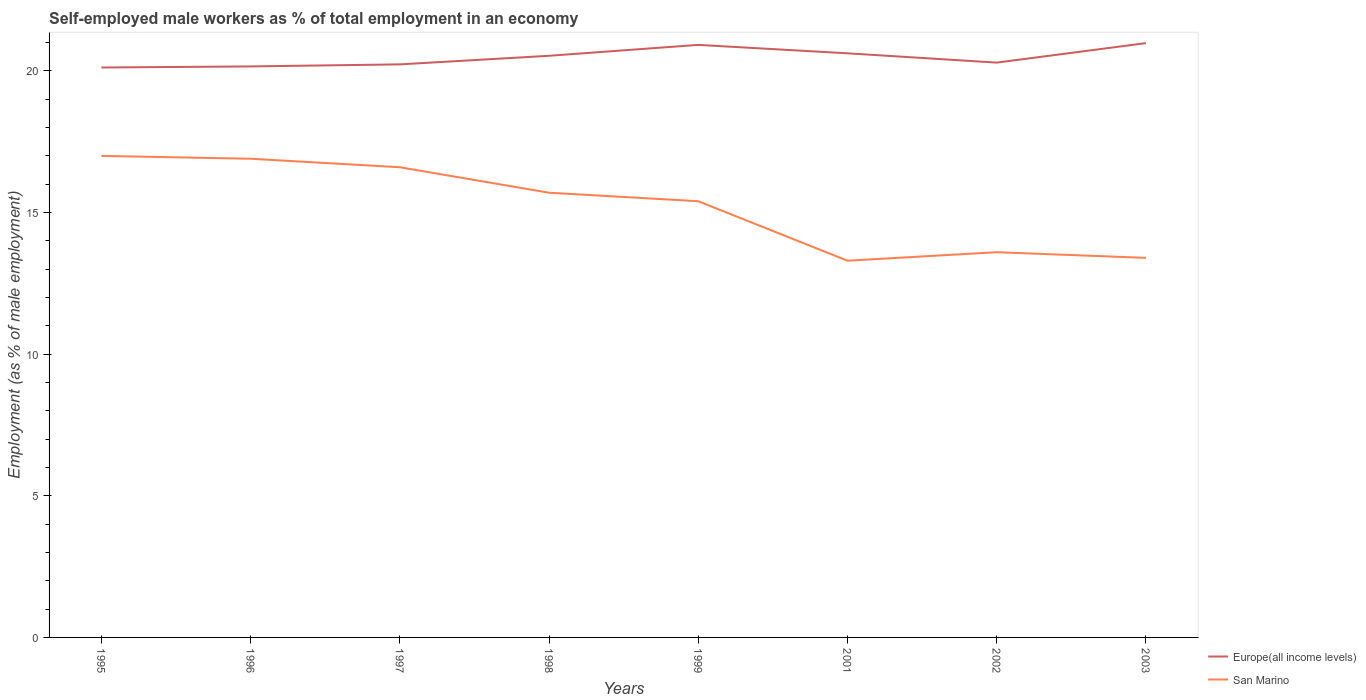Is the number of lines equal to the number of legend labels?
Your answer should be compact. Yes. Across all years, what is the maximum percentage of self-employed male workers in Europe(all income levels)?
Make the answer very short. 20.12. In which year was the percentage of self-employed male workers in Europe(all income levels) maximum?
Your response must be concise. 1995. What is the total percentage of self-employed male workers in Europe(all income levels) in the graph?
Give a very brief answer. -0.86. What is the difference between the highest and the second highest percentage of self-employed male workers in San Marino?
Offer a very short reply. 3.7. What is the difference between the highest and the lowest percentage of self-employed male workers in San Marino?
Keep it short and to the point. 5. Is the percentage of self-employed male workers in Europe(all income levels) strictly greater than the percentage of self-employed male workers in San Marino over the years?
Keep it short and to the point. No. How many lines are there?
Offer a very short reply. 2. How many years are there in the graph?
Your answer should be very brief. 8. What is the difference between two consecutive major ticks on the Y-axis?
Your answer should be compact. 5. Are the values on the major ticks of Y-axis written in scientific E-notation?
Make the answer very short. No. Does the graph contain any zero values?
Your answer should be very brief. No. How are the legend labels stacked?
Offer a very short reply. Vertical. What is the title of the graph?
Provide a succinct answer. Self-employed male workers as % of total employment in an economy. Does "Sri Lanka" appear as one of the legend labels in the graph?
Offer a very short reply. No. What is the label or title of the X-axis?
Give a very brief answer. Years. What is the label or title of the Y-axis?
Provide a succinct answer. Employment (as % of male employment). What is the Employment (as % of male employment) of Europe(all income levels) in 1995?
Your answer should be compact. 20.12. What is the Employment (as % of male employment) in Europe(all income levels) in 1996?
Offer a very short reply. 20.16. What is the Employment (as % of male employment) of San Marino in 1996?
Offer a terse response. 16.9. What is the Employment (as % of male employment) in Europe(all income levels) in 1997?
Ensure brevity in your answer.  20.23. What is the Employment (as % of male employment) of San Marino in 1997?
Keep it short and to the point. 16.6. What is the Employment (as % of male employment) of Europe(all income levels) in 1998?
Your response must be concise. 20.53. What is the Employment (as % of male employment) of San Marino in 1998?
Your response must be concise. 15.7. What is the Employment (as % of male employment) of Europe(all income levels) in 1999?
Offer a very short reply. 20.92. What is the Employment (as % of male employment) in San Marino in 1999?
Your answer should be compact. 15.4. What is the Employment (as % of male employment) in Europe(all income levels) in 2001?
Your answer should be compact. 20.62. What is the Employment (as % of male employment) in San Marino in 2001?
Ensure brevity in your answer.  13.3. What is the Employment (as % of male employment) in Europe(all income levels) in 2002?
Offer a terse response. 20.29. What is the Employment (as % of male employment) of San Marino in 2002?
Offer a terse response. 13.6. What is the Employment (as % of male employment) in Europe(all income levels) in 2003?
Provide a succinct answer. 20.98. What is the Employment (as % of male employment) in San Marino in 2003?
Provide a succinct answer. 13.4. Across all years, what is the maximum Employment (as % of male employment) in Europe(all income levels)?
Keep it short and to the point. 20.98. Across all years, what is the maximum Employment (as % of male employment) of San Marino?
Provide a short and direct response. 17. Across all years, what is the minimum Employment (as % of male employment) in Europe(all income levels)?
Provide a short and direct response. 20.12. Across all years, what is the minimum Employment (as % of male employment) in San Marino?
Ensure brevity in your answer.  13.3. What is the total Employment (as % of male employment) in Europe(all income levels) in the graph?
Provide a succinct answer. 163.86. What is the total Employment (as % of male employment) in San Marino in the graph?
Your answer should be very brief. 121.9. What is the difference between the Employment (as % of male employment) in Europe(all income levels) in 1995 and that in 1996?
Make the answer very short. -0.04. What is the difference between the Employment (as % of male employment) of Europe(all income levels) in 1995 and that in 1997?
Your answer should be very brief. -0.11. What is the difference between the Employment (as % of male employment) in Europe(all income levels) in 1995 and that in 1998?
Your answer should be compact. -0.41. What is the difference between the Employment (as % of male employment) in San Marino in 1995 and that in 1998?
Your answer should be very brief. 1.3. What is the difference between the Employment (as % of male employment) of Europe(all income levels) in 1995 and that in 1999?
Your answer should be very brief. -0.8. What is the difference between the Employment (as % of male employment) of San Marino in 1995 and that in 1999?
Provide a succinct answer. 1.6. What is the difference between the Employment (as % of male employment) in Europe(all income levels) in 1995 and that in 2001?
Give a very brief answer. -0.5. What is the difference between the Employment (as % of male employment) of San Marino in 1995 and that in 2001?
Provide a succinct answer. 3.7. What is the difference between the Employment (as % of male employment) of Europe(all income levels) in 1995 and that in 2002?
Keep it short and to the point. -0.17. What is the difference between the Employment (as % of male employment) in San Marino in 1995 and that in 2002?
Ensure brevity in your answer.  3.4. What is the difference between the Employment (as % of male employment) in Europe(all income levels) in 1995 and that in 2003?
Your response must be concise. -0.86. What is the difference between the Employment (as % of male employment) in Europe(all income levels) in 1996 and that in 1997?
Ensure brevity in your answer.  -0.07. What is the difference between the Employment (as % of male employment) of Europe(all income levels) in 1996 and that in 1998?
Your answer should be compact. -0.38. What is the difference between the Employment (as % of male employment) of Europe(all income levels) in 1996 and that in 1999?
Your response must be concise. -0.76. What is the difference between the Employment (as % of male employment) of Europe(all income levels) in 1996 and that in 2001?
Ensure brevity in your answer.  -0.46. What is the difference between the Employment (as % of male employment) in San Marino in 1996 and that in 2001?
Keep it short and to the point. 3.6. What is the difference between the Employment (as % of male employment) in Europe(all income levels) in 1996 and that in 2002?
Your answer should be very brief. -0.13. What is the difference between the Employment (as % of male employment) in San Marino in 1996 and that in 2002?
Ensure brevity in your answer.  3.3. What is the difference between the Employment (as % of male employment) of Europe(all income levels) in 1996 and that in 2003?
Your answer should be compact. -0.82. What is the difference between the Employment (as % of male employment) of Europe(all income levels) in 1997 and that in 1998?
Provide a succinct answer. -0.3. What is the difference between the Employment (as % of male employment) in Europe(all income levels) in 1997 and that in 1999?
Your answer should be very brief. -0.69. What is the difference between the Employment (as % of male employment) in San Marino in 1997 and that in 1999?
Keep it short and to the point. 1.2. What is the difference between the Employment (as % of male employment) of Europe(all income levels) in 1997 and that in 2001?
Keep it short and to the point. -0.39. What is the difference between the Employment (as % of male employment) in Europe(all income levels) in 1997 and that in 2002?
Ensure brevity in your answer.  -0.06. What is the difference between the Employment (as % of male employment) of Europe(all income levels) in 1997 and that in 2003?
Keep it short and to the point. -0.75. What is the difference between the Employment (as % of male employment) in Europe(all income levels) in 1998 and that in 1999?
Provide a succinct answer. -0.39. What is the difference between the Employment (as % of male employment) of San Marino in 1998 and that in 1999?
Keep it short and to the point. 0.3. What is the difference between the Employment (as % of male employment) in Europe(all income levels) in 1998 and that in 2001?
Offer a very short reply. -0.09. What is the difference between the Employment (as % of male employment) of San Marino in 1998 and that in 2001?
Ensure brevity in your answer.  2.4. What is the difference between the Employment (as % of male employment) in Europe(all income levels) in 1998 and that in 2002?
Your answer should be very brief. 0.24. What is the difference between the Employment (as % of male employment) in San Marino in 1998 and that in 2002?
Keep it short and to the point. 2.1. What is the difference between the Employment (as % of male employment) of Europe(all income levels) in 1998 and that in 2003?
Provide a succinct answer. -0.45. What is the difference between the Employment (as % of male employment) in San Marino in 1998 and that in 2003?
Provide a succinct answer. 2.3. What is the difference between the Employment (as % of male employment) in Europe(all income levels) in 1999 and that in 2001?
Your answer should be compact. 0.3. What is the difference between the Employment (as % of male employment) of Europe(all income levels) in 1999 and that in 2002?
Offer a terse response. 0.63. What is the difference between the Employment (as % of male employment) in Europe(all income levels) in 1999 and that in 2003?
Offer a terse response. -0.06. What is the difference between the Employment (as % of male employment) in San Marino in 1999 and that in 2003?
Your response must be concise. 2. What is the difference between the Employment (as % of male employment) of Europe(all income levels) in 2001 and that in 2002?
Keep it short and to the point. 0.33. What is the difference between the Employment (as % of male employment) of Europe(all income levels) in 2001 and that in 2003?
Provide a succinct answer. -0.36. What is the difference between the Employment (as % of male employment) in Europe(all income levels) in 2002 and that in 2003?
Your response must be concise. -0.69. What is the difference between the Employment (as % of male employment) of Europe(all income levels) in 1995 and the Employment (as % of male employment) of San Marino in 1996?
Keep it short and to the point. 3.22. What is the difference between the Employment (as % of male employment) of Europe(all income levels) in 1995 and the Employment (as % of male employment) of San Marino in 1997?
Offer a terse response. 3.52. What is the difference between the Employment (as % of male employment) of Europe(all income levels) in 1995 and the Employment (as % of male employment) of San Marino in 1998?
Offer a very short reply. 4.42. What is the difference between the Employment (as % of male employment) of Europe(all income levels) in 1995 and the Employment (as % of male employment) of San Marino in 1999?
Your answer should be compact. 4.72. What is the difference between the Employment (as % of male employment) in Europe(all income levels) in 1995 and the Employment (as % of male employment) in San Marino in 2001?
Keep it short and to the point. 6.82. What is the difference between the Employment (as % of male employment) of Europe(all income levels) in 1995 and the Employment (as % of male employment) of San Marino in 2002?
Your answer should be very brief. 6.52. What is the difference between the Employment (as % of male employment) of Europe(all income levels) in 1995 and the Employment (as % of male employment) of San Marino in 2003?
Keep it short and to the point. 6.72. What is the difference between the Employment (as % of male employment) of Europe(all income levels) in 1996 and the Employment (as % of male employment) of San Marino in 1997?
Ensure brevity in your answer.  3.56. What is the difference between the Employment (as % of male employment) in Europe(all income levels) in 1996 and the Employment (as % of male employment) in San Marino in 1998?
Give a very brief answer. 4.46. What is the difference between the Employment (as % of male employment) of Europe(all income levels) in 1996 and the Employment (as % of male employment) of San Marino in 1999?
Make the answer very short. 4.76. What is the difference between the Employment (as % of male employment) in Europe(all income levels) in 1996 and the Employment (as % of male employment) in San Marino in 2001?
Give a very brief answer. 6.86. What is the difference between the Employment (as % of male employment) of Europe(all income levels) in 1996 and the Employment (as % of male employment) of San Marino in 2002?
Ensure brevity in your answer.  6.56. What is the difference between the Employment (as % of male employment) in Europe(all income levels) in 1996 and the Employment (as % of male employment) in San Marino in 2003?
Offer a terse response. 6.76. What is the difference between the Employment (as % of male employment) in Europe(all income levels) in 1997 and the Employment (as % of male employment) in San Marino in 1998?
Offer a terse response. 4.53. What is the difference between the Employment (as % of male employment) of Europe(all income levels) in 1997 and the Employment (as % of male employment) of San Marino in 1999?
Your answer should be very brief. 4.83. What is the difference between the Employment (as % of male employment) of Europe(all income levels) in 1997 and the Employment (as % of male employment) of San Marino in 2001?
Give a very brief answer. 6.93. What is the difference between the Employment (as % of male employment) of Europe(all income levels) in 1997 and the Employment (as % of male employment) of San Marino in 2002?
Offer a very short reply. 6.63. What is the difference between the Employment (as % of male employment) in Europe(all income levels) in 1997 and the Employment (as % of male employment) in San Marino in 2003?
Your answer should be very brief. 6.83. What is the difference between the Employment (as % of male employment) in Europe(all income levels) in 1998 and the Employment (as % of male employment) in San Marino in 1999?
Offer a terse response. 5.13. What is the difference between the Employment (as % of male employment) of Europe(all income levels) in 1998 and the Employment (as % of male employment) of San Marino in 2001?
Give a very brief answer. 7.23. What is the difference between the Employment (as % of male employment) of Europe(all income levels) in 1998 and the Employment (as % of male employment) of San Marino in 2002?
Make the answer very short. 6.93. What is the difference between the Employment (as % of male employment) in Europe(all income levels) in 1998 and the Employment (as % of male employment) in San Marino in 2003?
Give a very brief answer. 7.13. What is the difference between the Employment (as % of male employment) of Europe(all income levels) in 1999 and the Employment (as % of male employment) of San Marino in 2001?
Provide a short and direct response. 7.62. What is the difference between the Employment (as % of male employment) of Europe(all income levels) in 1999 and the Employment (as % of male employment) of San Marino in 2002?
Offer a terse response. 7.32. What is the difference between the Employment (as % of male employment) in Europe(all income levels) in 1999 and the Employment (as % of male employment) in San Marino in 2003?
Give a very brief answer. 7.52. What is the difference between the Employment (as % of male employment) in Europe(all income levels) in 2001 and the Employment (as % of male employment) in San Marino in 2002?
Give a very brief answer. 7.02. What is the difference between the Employment (as % of male employment) of Europe(all income levels) in 2001 and the Employment (as % of male employment) of San Marino in 2003?
Your answer should be compact. 7.22. What is the difference between the Employment (as % of male employment) of Europe(all income levels) in 2002 and the Employment (as % of male employment) of San Marino in 2003?
Provide a short and direct response. 6.89. What is the average Employment (as % of male employment) of Europe(all income levels) per year?
Your answer should be very brief. 20.48. What is the average Employment (as % of male employment) of San Marino per year?
Your answer should be very brief. 15.24. In the year 1995, what is the difference between the Employment (as % of male employment) in Europe(all income levels) and Employment (as % of male employment) in San Marino?
Your answer should be very brief. 3.12. In the year 1996, what is the difference between the Employment (as % of male employment) in Europe(all income levels) and Employment (as % of male employment) in San Marino?
Offer a very short reply. 3.26. In the year 1997, what is the difference between the Employment (as % of male employment) in Europe(all income levels) and Employment (as % of male employment) in San Marino?
Keep it short and to the point. 3.63. In the year 1998, what is the difference between the Employment (as % of male employment) in Europe(all income levels) and Employment (as % of male employment) in San Marino?
Your answer should be compact. 4.83. In the year 1999, what is the difference between the Employment (as % of male employment) in Europe(all income levels) and Employment (as % of male employment) in San Marino?
Your answer should be very brief. 5.52. In the year 2001, what is the difference between the Employment (as % of male employment) of Europe(all income levels) and Employment (as % of male employment) of San Marino?
Ensure brevity in your answer.  7.32. In the year 2002, what is the difference between the Employment (as % of male employment) in Europe(all income levels) and Employment (as % of male employment) in San Marino?
Offer a very short reply. 6.69. In the year 2003, what is the difference between the Employment (as % of male employment) in Europe(all income levels) and Employment (as % of male employment) in San Marino?
Your response must be concise. 7.58. What is the ratio of the Employment (as % of male employment) of San Marino in 1995 to that in 1996?
Your response must be concise. 1.01. What is the ratio of the Employment (as % of male employment) in Europe(all income levels) in 1995 to that in 1997?
Ensure brevity in your answer.  0.99. What is the ratio of the Employment (as % of male employment) in San Marino in 1995 to that in 1997?
Ensure brevity in your answer.  1.02. What is the ratio of the Employment (as % of male employment) in Europe(all income levels) in 1995 to that in 1998?
Provide a succinct answer. 0.98. What is the ratio of the Employment (as % of male employment) of San Marino in 1995 to that in 1998?
Your answer should be compact. 1.08. What is the ratio of the Employment (as % of male employment) in Europe(all income levels) in 1995 to that in 1999?
Provide a short and direct response. 0.96. What is the ratio of the Employment (as % of male employment) of San Marino in 1995 to that in 1999?
Your response must be concise. 1.1. What is the ratio of the Employment (as % of male employment) of Europe(all income levels) in 1995 to that in 2001?
Offer a very short reply. 0.98. What is the ratio of the Employment (as % of male employment) in San Marino in 1995 to that in 2001?
Provide a short and direct response. 1.28. What is the ratio of the Employment (as % of male employment) of Europe(all income levels) in 1995 to that in 2002?
Your response must be concise. 0.99. What is the ratio of the Employment (as % of male employment) of San Marino in 1995 to that in 2002?
Your response must be concise. 1.25. What is the ratio of the Employment (as % of male employment) of San Marino in 1995 to that in 2003?
Offer a terse response. 1.27. What is the ratio of the Employment (as % of male employment) of San Marino in 1996 to that in 1997?
Give a very brief answer. 1.02. What is the ratio of the Employment (as % of male employment) in Europe(all income levels) in 1996 to that in 1998?
Ensure brevity in your answer.  0.98. What is the ratio of the Employment (as % of male employment) in San Marino in 1996 to that in 1998?
Your response must be concise. 1.08. What is the ratio of the Employment (as % of male employment) of Europe(all income levels) in 1996 to that in 1999?
Provide a short and direct response. 0.96. What is the ratio of the Employment (as % of male employment) of San Marino in 1996 to that in 1999?
Ensure brevity in your answer.  1.1. What is the ratio of the Employment (as % of male employment) in Europe(all income levels) in 1996 to that in 2001?
Ensure brevity in your answer.  0.98. What is the ratio of the Employment (as % of male employment) of San Marino in 1996 to that in 2001?
Your response must be concise. 1.27. What is the ratio of the Employment (as % of male employment) in San Marino in 1996 to that in 2002?
Give a very brief answer. 1.24. What is the ratio of the Employment (as % of male employment) in Europe(all income levels) in 1996 to that in 2003?
Make the answer very short. 0.96. What is the ratio of the Employment (as % of male employment) in San Marino in 1996 to that in 2003?
Your answer should be very brief. 1.26. What is the ratio of the Employment (as % of male employment) in Europe(all income levels) in 1997 to that in 1998?
Provide a short and direct response. 0.99. What is the ratio of the Employment (as % of male employment) of San Marino in 1997 to that in 1998?
Offer a very short reply. 1.06. What is the ratio of the Employment (as % of male employment) in Europe(all income levels) in 1997 to that in 1999?
Provide a short and direct response. 0.97. What is the ratio of the Employment (as % of male employment) in San Marino in 1997 to that in 1999?
Ensure brevity in your answer.  1.08. What is the ratio of the Employment (as % of male employment) in Europe(all income levels) in 1997 to that in 2001?
Your answer should be compact. 0.98. What is the ratio of the Employment (as % of male employment) in San Marino in 1997 to that in 2001?
Provide a short and direct response. 1.25. What is the ratio of the Employment (as % of male employment) of San Marino in 1997 to that in 2002?
Provide a succinct answer. 1.22. What is the ratio of the Employment (as % of male employment) in Europe(all income levels) in 1997 to that in 2003?
Keep it short and to the point. 0.96. What is the ratio of the Employment (as % of male employment) of San Marino in 1997 to that in 2003?
Make the answer very short. 1.24. What is the ratio of the Employment (as % of male employment) in Europe(all income levels) in 1998 to that in 1999?
Your response must be concise. 0.98. What is the ratio of the Employment (as % of male employment) of San Marino in 1998 to that in 1999?
Make the answer very short. 1.02. What is the ratio of the Employment (as % of male employment) of Europe(all income levels) in 1998 to that in 2001?
Make the answer very short. 1. What is the ratio of the Employment (as % of male employment) in San Marino in 1998 to that in 2001?
Your answer should be very brief. 1.18. What is the ratio of the Employment (as % of male employment) in Europe(all income levels) in 1998 to that in 2002?
Your answer should be compact. 1.01. What is the ratio of the Employment (as % of male employment) in San Marino in 1998 to that in 2002?
Provide a short and direct response. 1.15. What is the ratio of the Employment (as % of male employment) of Europe(all income levels) in 1998 to that in 2003?
Your response must be concise. 0.98. What is the ratio of the Employment (as % of male employment) of San Marino in 1998 to that in 2003?
Your response must be concise. 1.17. What is the ratio of the Employment (as % of male employment) of Europe(all income levels) in 1999 to that in 2001?
Ensure brevity in your answer.  1.01. What is the ratio of the Employment (as % of male employment) of San Marino in 1999 to that in 2001?
Your answer should be compact. 1.16. What is the ratio of the Employment (as % of male employment) in Europe(all income levels) in 1999 to that in 2002?
Your answer should be very brief. 1.03. What is the ratio of the Employment (as % of male employment) in San Marino in 1999 to that in 2002?
Your response must be concise. 1.13. What is the ratio of the Employment (as % of male employment) of Europe(all income levels) in 1999 to that in 2003?
Provide a short and direct response. 1. What is the ratio of the Employment (as % of male employment) in San Marino in 1999 to that in 2003?
Your answer should be very brief. 1.15. What is the ratio of the Employment (as % of male employment) of Europe(all income levels) in 2001 to that in 2002?
Offer a terse response. 1.02. What is the ratio of the Employment (as % of male employment) of San Marino in 2001 to that in 2002?
Your response must be concise. 0.98. What is the ratio of the Employment (as % of male employment) in Europe(all income levels) in 2001 to that in 2003?
Make the answer very short. 0.98. What is the ratio of the Employment (as % of male employment) in Europe(all income levels) in 2002 to that in 2003?
Offer a terse response. 0.97. What is the ratio of the Employment (as % of male employment) of San Marino in 2002 to that in 2003?
Your response must be concise. 1.01. What is the difference between the highest and the second highest Employment (as % of male employment) in Europe(all income levels)?
Offer a terse response. 0.06. What is the difference between the highest and the second highest Employment (as % of male employment) of San Marino?
Offer a terse response. 0.1. What is the difference between the highest and the lowest Employment (as % of male employment) in Europe(all income levels)?
Your answer should be compact. 0.86. 